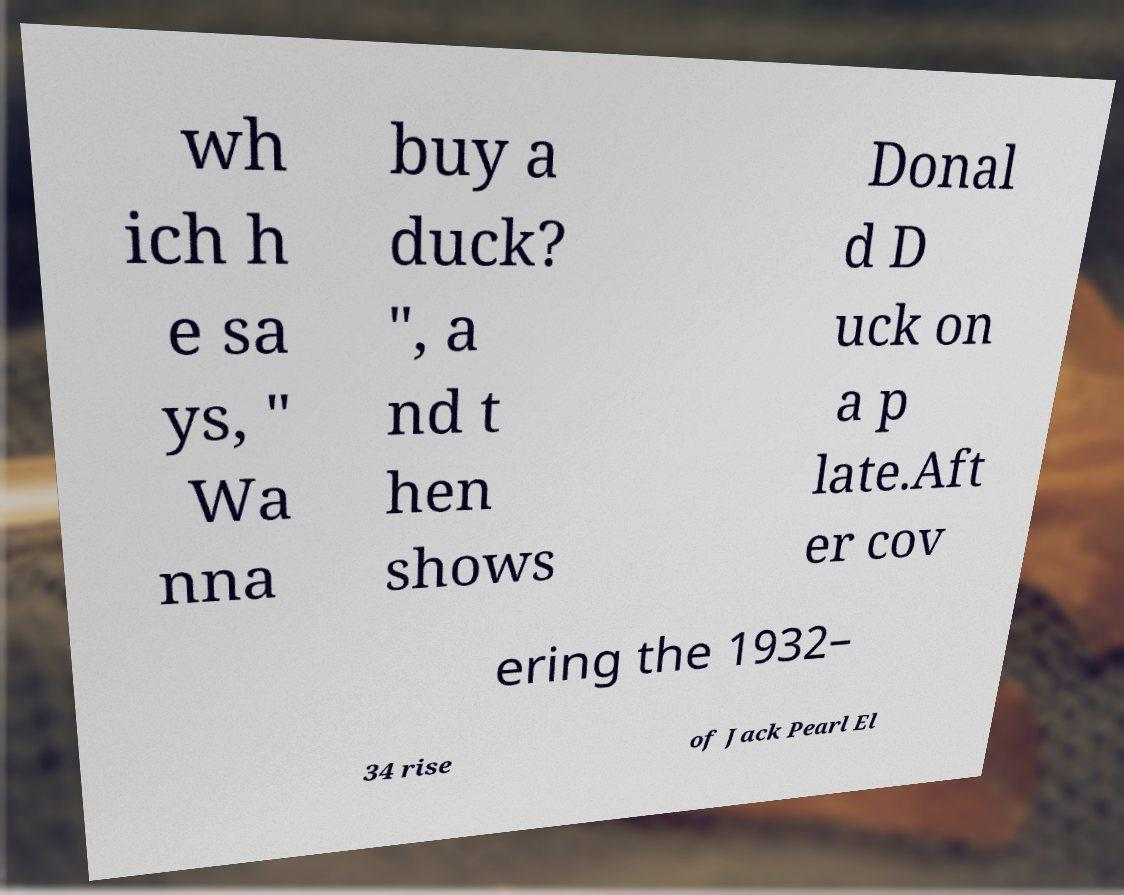For documentation purposes, I need the text within this image transcribed. Could you provide that? wh ich h e sa ys, " Wa nna buy a duck? ", a nd t hen shows Donal d D uck on a p late.Aft er cov ering the 1932– 34 rise of Jack Pearl El 